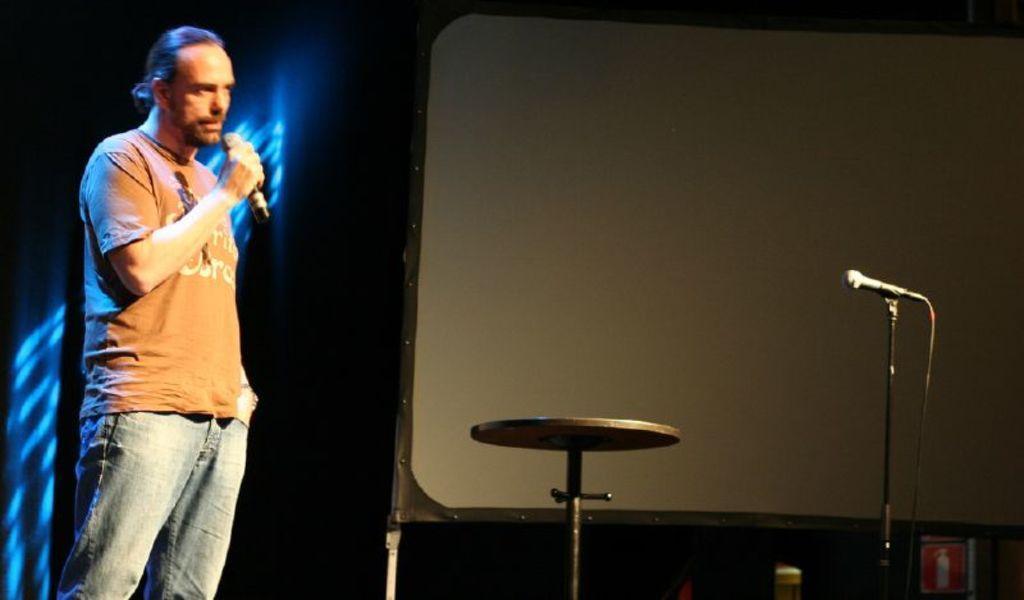Could you give a brief overview of what you see in this image? This picture shows a man standing and speaking with the help of a microphone. 